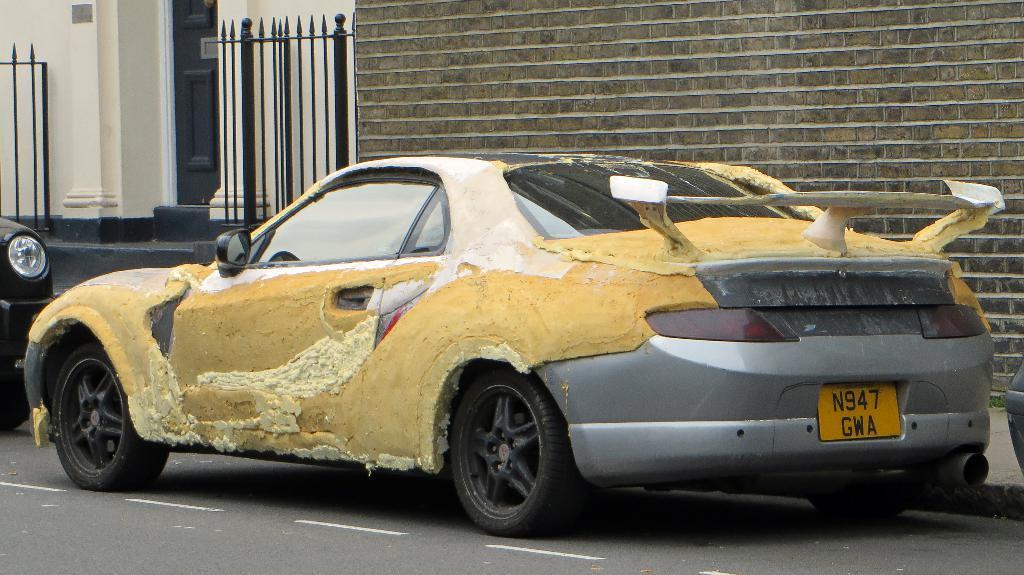In one or two sentences, can you explain what this image depicts? In this image I can see two cars on the road. Beside the road there is a wall. On the the left top of the image I can see a building and black color doors to that and also there is a fencing. 